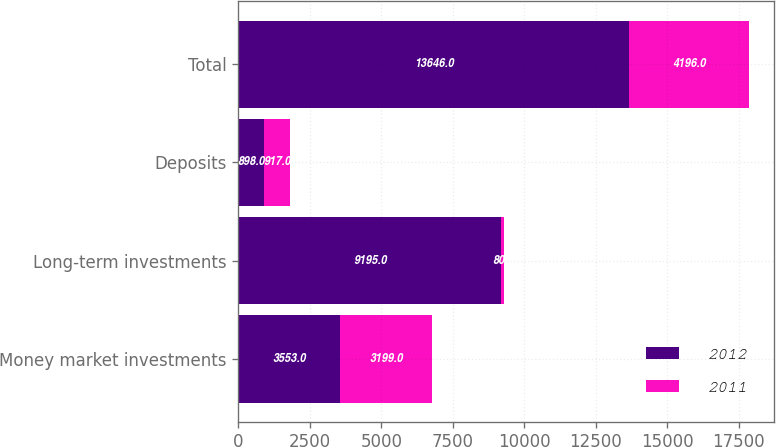Convert chart. <chart><loc_0><loc_0><loc_500><loc_500><stacked_bar_chart><ecel><fcel>Money market investments<fcel>Long-term investments<fcel>Deposits<fcel>Total<nl><fcel>2012<fcel>3553<fcel>9195<fcel>898<fcel>13646<nl><fcel>2011<fcel>3199<fcel>80<fcel>917<fcel>4196<nl></chart> 